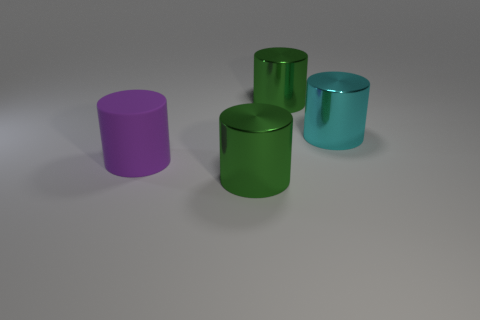Subtract all green blocks. How many green cylinders are left? 2 Subtract 1 cylinders. How many cylinders are left? 3 Subtract all purple cylinders. How many cylinders are left? 3 Subtract all cyan metal cylinders. How many cylinders are left? 3 Add 2 red matte blocks. How many objects exist? 6 Subtract all gray cylinders. Subtract all yellow balls. How many cylinders are left? 4 Add 4 big cyan cylinders. How many big cyan cylinders exist? 5 Subtract 0 brown cylinders. How many objects are left? 4 Subtract all big red rubber blocks. Subtract all large green cylinders. How many objects are left? 2 Add 3 green metallic things. How many green metallic things are left? 5 